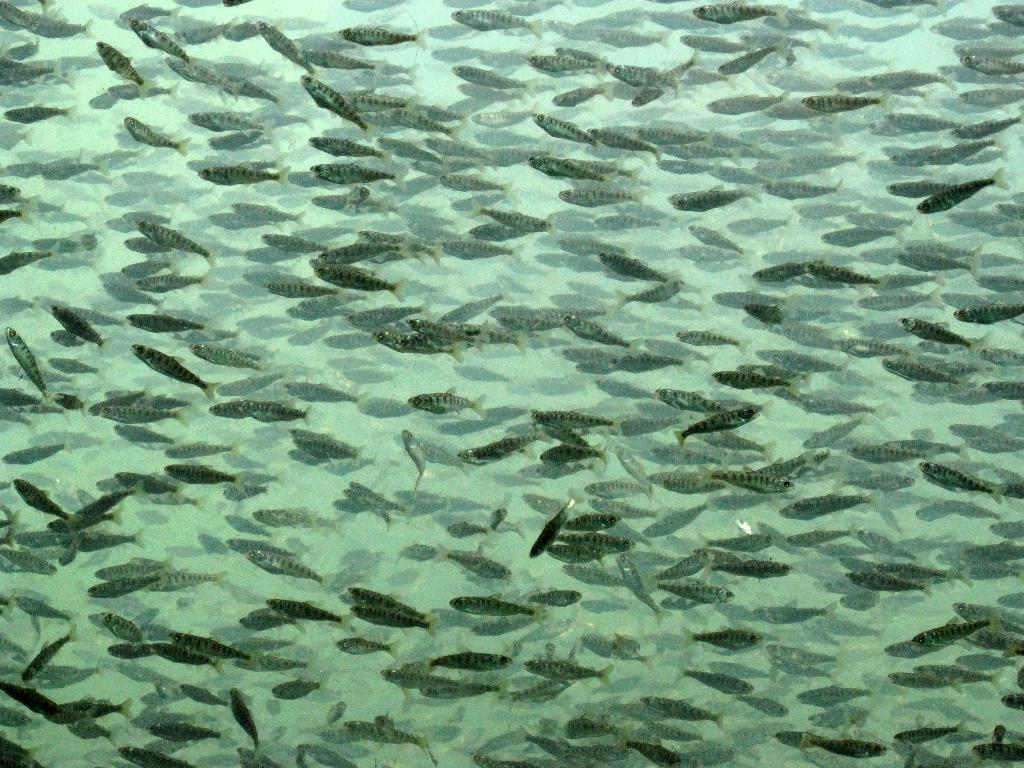What type of animals can be seen in the image? There are fishes in the image. Where are the fishes located? The fishes are in the water. What type of clam is being used as a recess bell in the image? There is no clam or recess bell present in the image; it features fishes in the water. 